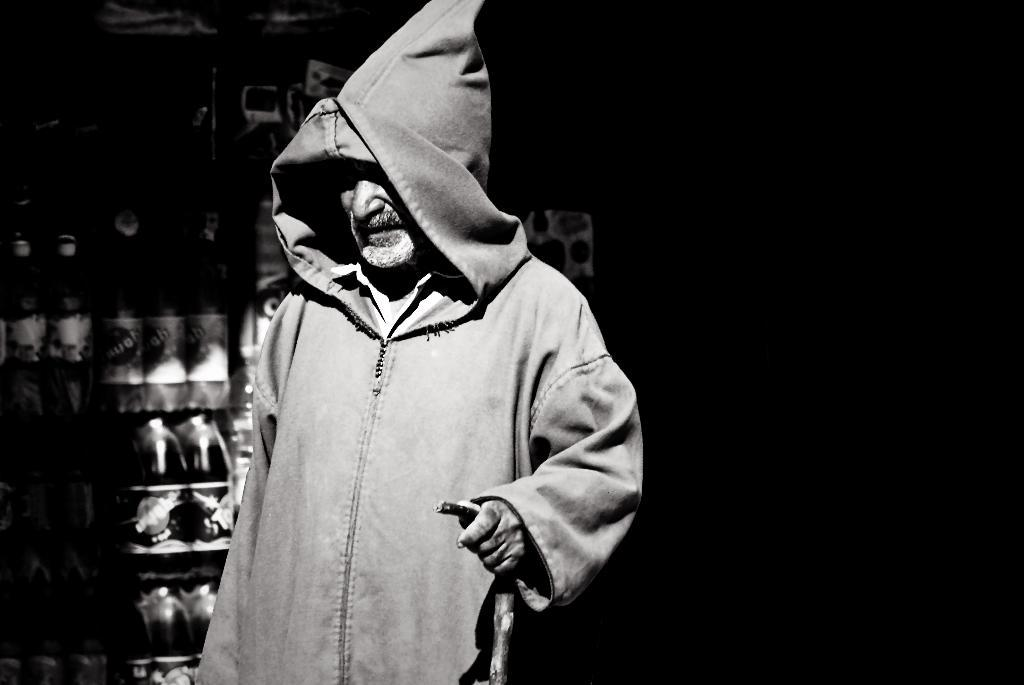What can be seen in the image? There is a person in the image. Can you describe the person's clothing? The person is wearing a hooded jacket. What is the person holding in his hand? The person is holding a stick in his hand. Are there any other items visible in the image? Yes, there are packed bottled drinks visible in the image. What type of gold jewelry is the person wearing in the image? There is no gold jewelry visible on the person in the image. Can you describe the berries that the person is holding in their hand? The person is not holding any berries in their hand; they are holding a stick. 